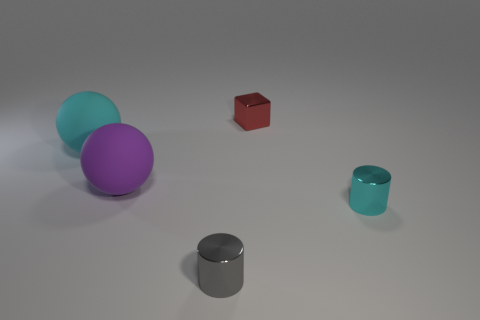Add 3 gray objects. How many objects exist? 8 Subtract all purple balls. How many balls are left? 1 Subtract 2 cylinders. How many cylinders are left? 0 Subtract all red blocks. How many red balls are left? 0 Subtract all balls. How many objects are left? 3 Subtract all brown spheres. Subtract all gray cylinders. How many spheres are left? 2 Subtract all things. Subtract all large gray objects. How many objects are left? 0 Add 1 purple objects. How many purple objects are left? 2 Add 4 metallic blocks. How many metallic blocks exist? 5 Subtract 1 cyan balls. How many objects are left? 4 